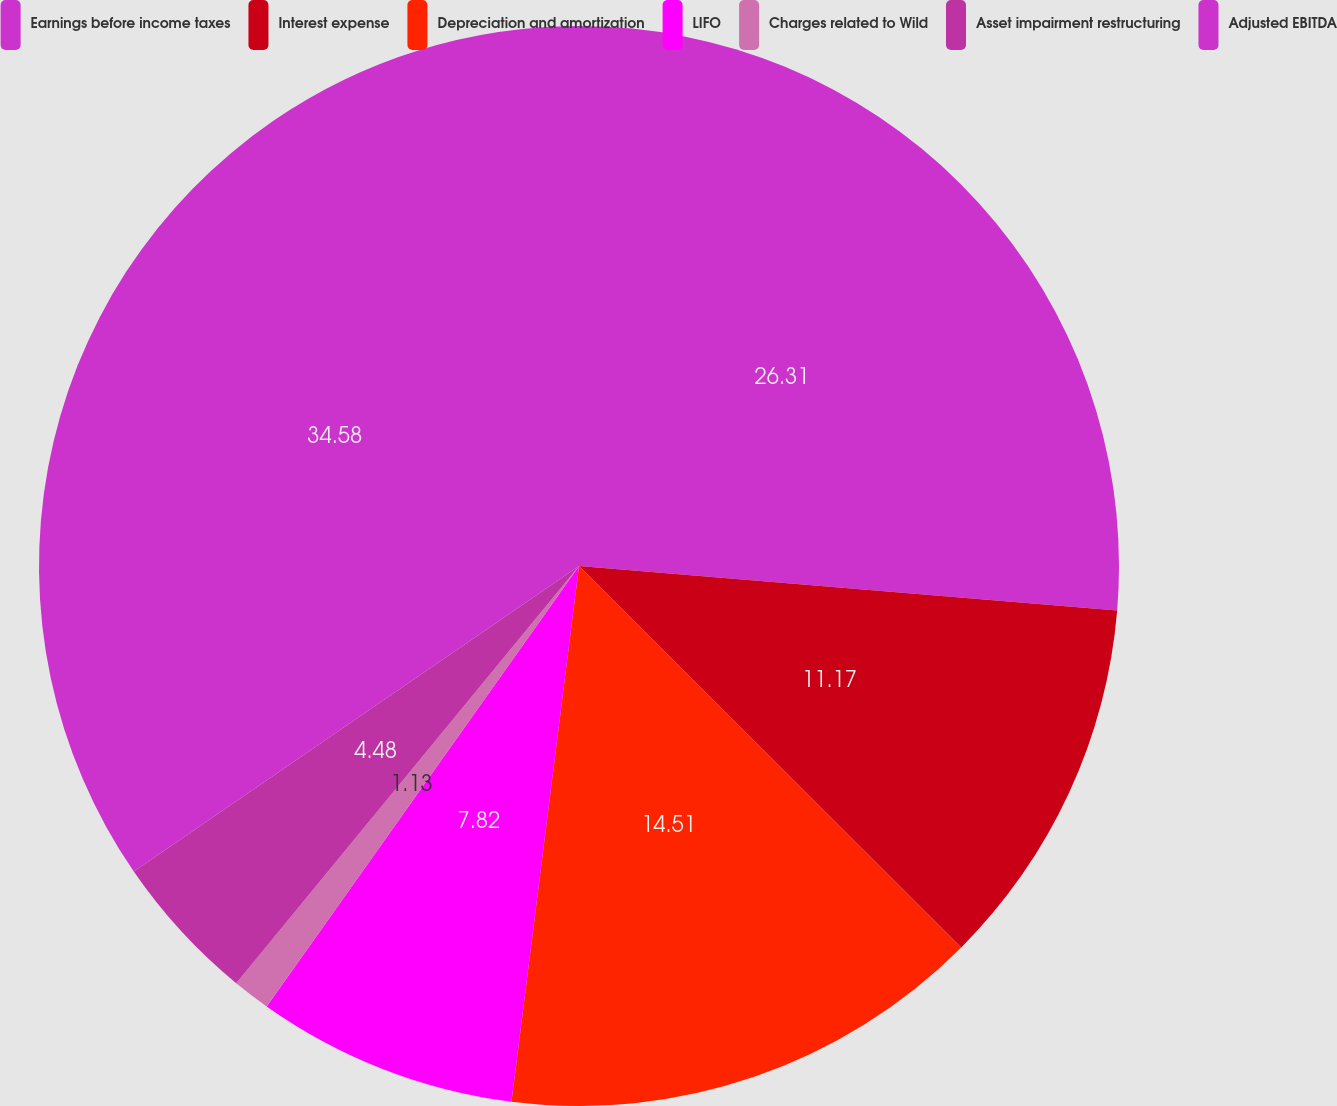Convert chart. <chart><loc_0><loc_0><loc_500><loc_500><pie_chart><fcel>Earnings before income taxes<fcel>Interest expense<fcel>Depreciation and amortization<fcel>LIFO<fcel>Charges related to Wild<fcel>Asset impairment restructuring<fcel>Adjusted EBITDA<nl><fcel>26.31%<fcel>11.17%<fcel>14.51%<fcel>7.82%<fcel>1.13%<fcel>4.48%<fcel>34.57%<nl></chart> 